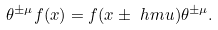<formula> <loc_0><loc_0><loc_500><loc_500>\theta ^ { \pm \mu } f ( x ) = f ( x \pm \ h m u ) \theta ^ { \pm \mu } .</formula> 